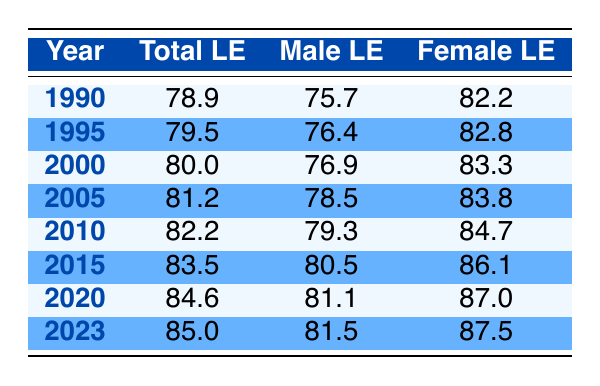What was the total life expectancy in Japan in 1990? In the table, find the row for the year 1990. The total life expectancy in that year is listed as 78.9 years.
Answer: 78.9 What is the life expectancy for males in Japan in 2015? In the row for the year 2015, the male life expectancy is noted as 80.5 years.
Answer: 80.5 In which year did the total life expectancy in Japan first exceed 80 years? By examining the rows, the total life expectancy exceeds 80 years for the first time in 2000, where it is recorded as 80.0.
Answer: 2000 What is the difference in female life expectancy between 1990 and 2023? The female life expectancy in 1990 is 82.2 years, and in 2023 it is 87.5 years. The difference is calculated as 87.5 - 82.2 = 5.3 years.
Answer: 5.3 Is the female life expectancy higher than the male life expectancy for all years listed? Reviewing the table shows that female life expectancy is consistently higher than male life expectancy across all years from 1990 to 2023.
Answer: Yes What is the average total life expectancy in Japan for the years 2005, 2010, and 2015? The total life expectancies for these years are 81.2 (2005), 82.2 (2010), and 83.5 (2015). First, sum these values: 81.2 + 82.2 + 83.5 = 246.9. Then, divide by 3 to get the average: 246.9 / 3 = 82.3.
Answer: 82.3 How much has the male life expectancy increased from 1990 to 2020? The male life expectancy in 1990 is 75.7 years, and in 2020 it is 81.1 years. The increase is calculated as 81.1 - 75.7 = 5.4 years.
Answer: 5.4 What was the female life expectancy in Japan in 2005? Looking at the row for 2005, the female life expectancy is reported as 83.8 years.
Answer: 83.8 Did the total life expectancy in Japan increase every five years from 1990 to 2023? By examining the data for each five-year increment, it is clear that the total life expectancy increased every five years without any decreases in the years listed.
Answer: Yes 